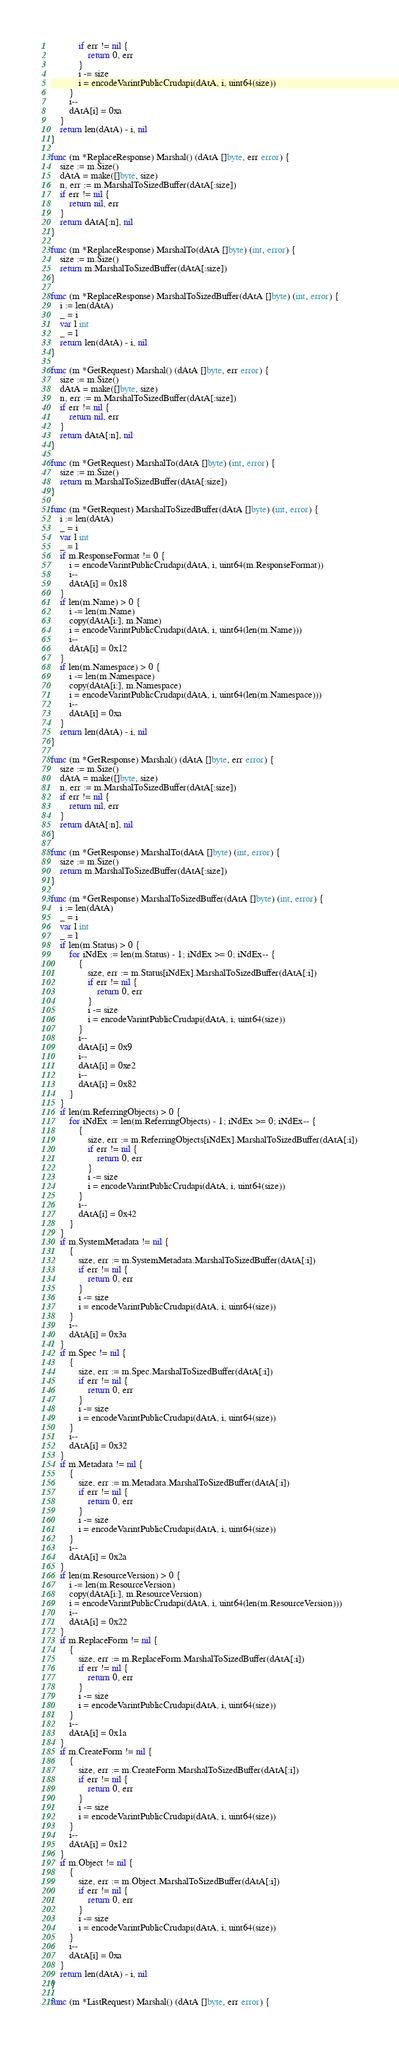Convert code to text. <code><loc_0><loc_0><loc_500><loc_500><_Go_>			if err != nil {
				return 0, err
			}
			i -= size
			i = encodeVarintPublicCrudapi(dAtA, i, uint64(size))
		}
		i--
		dAtA[i] = 0xa
	}
	return len(dAtA) - i, nil
}

func (m *ReplaceResponse) Marshal() (dAtA []byte, err error) {
	size := m.Size()
	dAtA = make([]byte, size)
	n, err := m.MarshalToSizedBuffer(dAtA[:size])
	if err != nil {
		return nil, err
	}
	return dAtA[:n], nil
}

func (m *ReplaceResponse) MarshalTo(dAtA []byte) (int, error) {
	size := m.Size()
	return m.MarshalToSizedBuffer(dAtA[:size])
}

func (m *ReplaceResponse) MarshalToSizedBuffer(dAtA []byte) (int, error) {
	i := len(dAtA)
	_ = i
	var l int
	_ = l
	return len(dAtA) - i, nil
}

func (m *GetRequest) Marshal() (dAtA []byte, err error) {
	size := m.Size()
	dAtA = make([]byte, size)
	n, err := m.MarshalToSizedBuffer(dAtA[:size])
	if err != nil {
		return nil, err
	}
	return dAtA[:n], nil
}

func (m *GetRequest) MarshalTo(dAtA []byte) (int, error) {
	size := m.Size()
	return m.MarshalToSizedBuffer(dAtA[:size])
}

func (m *GetRequest) MarshalToSizedBuffer(dAtA []byte) (int, error) {
	i := len(dAtA)
	_ = i
	var l int
	_ = l
	if m.ResponseFormat != 0 {
		i = encodeVarintPublicCrudapi(dAtA, i, uint64(m.ResponseFormat))
		i--
		dAtA[i] = 0x18
	}
	if len(m.Name) > 0 {
		i -= len(m.Name)
		copy(dAtA[i:], m.Name)
		i = encodeVarintPublicCrudapi(dAtA, i, uint64(len(m.Name)))
		i--
		dAtA[i] = 0x12
	}
	if len(m.Namespace) > 0 {
		i -= len(m.Namespace)
		copy(dAtA[i:], m.Namespace)
		i = encodeVarintPublicCrudapi(dAtA, i, uint64(len(m.Namespace)))
		i--
		dAtA[i] = 0xa
	}
	return len(dAtA) - i, nil
}

func (m *GetResponse) Marshal() (dAtA []byte, err error) {
	size := m.Size()
	dAtA = make([]byte, size)
	n, err := m.MarshalToSizedBuffer(dAtA[:size])
	if err != nil {
		return nil, err
	}
	return dAtA[:n], nil
}

func (m *GetResponse) MarshalTo(dAtA []byte) (int, error) {
	size := m.Size()
	return m.MarshalToSizedBuffer(dAtA[:size])
}

func (m *GetResponse) MarshalToSizedBuffer(dAtA []byte) (int, error) {
	i := len(dAtA)
	_ = i
	var l int
	_ = l
	if len(m.Status) > 0 {
		for iNdEx := len(m.Status) - 1; iNdEx >= 0; iNdEx-- {
			{
				size, err := m.Status[iNdEx].MarshalToSizedBuffer(dAtA[:i])
				if err != nil {
					return 0, err
				}
				i -= size
				i = encodeVarintPublicCrudapi(dAtA, i, uint64(size))
			}
			i--
			dAtA[i] = 0x9
			i--
			dAtA[i] = 0xe2
			i--
			dAtA[i] = 0x82
		}
	}
	if len(m.ReferringObjects) > 0 {
		for iNdEx := len(m.ReferringObjects) - 1; iNdEx >= 0; iNdEx-- {
			{
				size, err := m.ReferringObjects[iNdEx].MarshalToSizedBuffer(dAtA[:i])
				if err != nil {
					return 0, err
				}
				i -= size
				i = encodeVarintPublicCrudapi(dAtA, i, uint64(size))
			}
			i--
			dAtA[i] = 0x42
		}
	}
	if m.SystemMetadata != nil {
		{
			size, err := m.SystemMetadata.MarshalToSizedBuffer(dAtA[:i])
			if err != nil {
				return 0, err
			}
			i -= size
			i = encodeVarintPublicCrudapi(dAtA, i, uint64(size))
		}
		i--
		dAtA[i] = 0x3a
	}
	if m.Spec != nil {
		{
			size, err := m.Spec.MarshalToSizedBuffer(dAtA[:i])
			if err != nil {
				return 0, err
			}
			i -= size
			i = encodeVarintPublicCrudapi(dAtA, i, uint64(size))
		}
		i--
		dAtA[i] = 0x32
	}
	if m.Metadata != nil {
		{
			size, err := m.Metadata.MarshalToSizedBuffer(dAtA[:i])
			if err != nil {
				return 0, err
			}
			i -= size
			i = encodeVarintPublicCrudapi(dAtA, i, uint64(size))
		}
		i--
		dAtA[i] = 0x2a
	}
	if len(m.ResourceVersion) > 0 {
		i -= len(m.ResourceVersion)
		copy(dAtA[i:], m.ResourceVersion)
		i = encodeVarintPublicCrudapi(dAtA, i, uint64(len(m.ResourceVersion)))
		i--
		dAtA[i] = 0x22
	}
	if m.ReplaceForm != nil {
		{
			size, err := m.ReplaceForm.MarshalToSizedBuffer(dAtA[:i])
			if err != nil {
				return 0, err
			}
			i -= size
			i = encodeVarintPublicCrudapi(dAtA, i, uint64(size))
		}
		i--
		dAtA[i] = 0x1a
	}
	if m.CreateForm != nil {
		{
			size, err := m.CreateForm.MarshalToSizedBuffer(dAtA[:i])
			if err != nil {
				return 0, err
			}
			i -= size
			i = encodeVarintPublicCrudapi(dAtA, i, uint64(size))
		}
		i--
		dAtA[i] = 0x12
	}
	if m.Object != nil {
		{
			size, err := m.Object.MarshalToSizedBuffer(dAtA[:i])
			if err != nil {
				return 0, err
			}
			i -= size
			i = encodeVarintPublicCrudapi(dAtA, i, uint64(size))
		}
		i--
		dAtA[i] = 0xa
	}
	return len(dAtA) - i, nil
}

func (m *ListRequest) Marshal() (dAtA []byte, err error) {</code> 